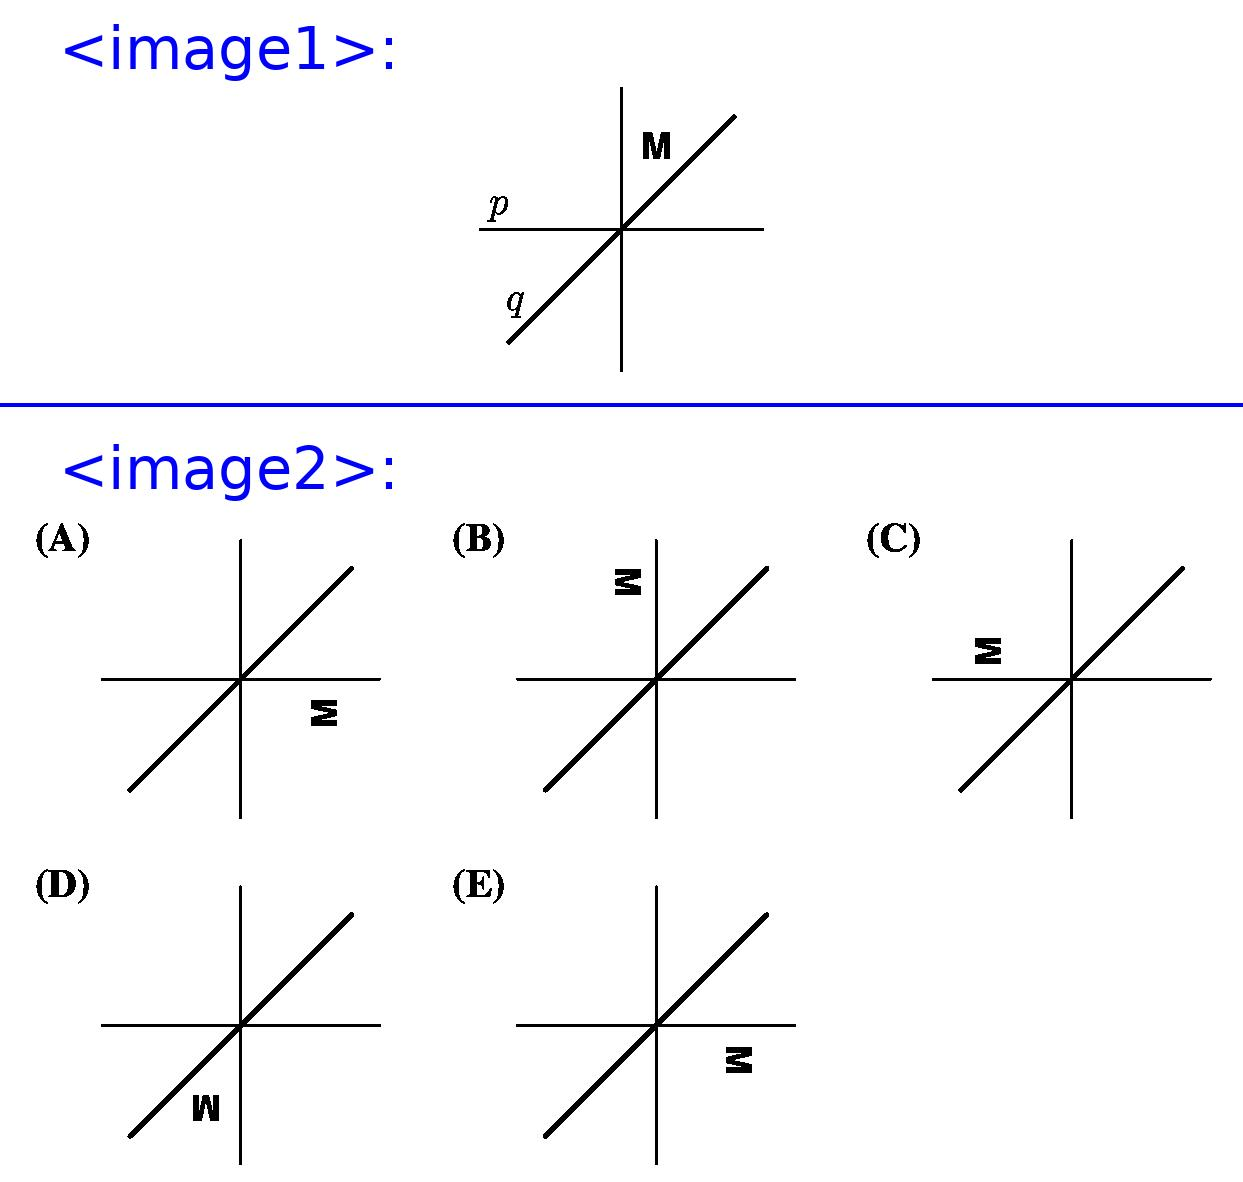The letter M in the figure below is first reflected over the line $q$ and then reflected over the line $p$. What is the resulting image? To solve this geometry problem, we start by reflecting the letter 'M' over line 'q'. Reflecting 'M' in this manner will flip it to the other side of the line 'q'. Consequently, the next step is to reflect this new image over line 'p'. After performing these transformations, the new position and orientation of 'M' will match option 'D' from the choices provided. 